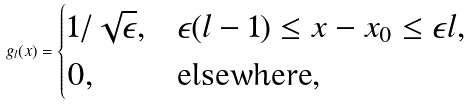Convert formula to latex. <formula><loc_0><loc_0><loc_500><loc_500>g _ { l } ( x ) = \begin{cases} 1 / \sqrt { \epsilon } , & \epsilon ( l - 1 ) \leq x - x _ { 0 } \leq \epsilon l , \\ 0 , & \text {elsewhere} , \end{cases}</formula> 